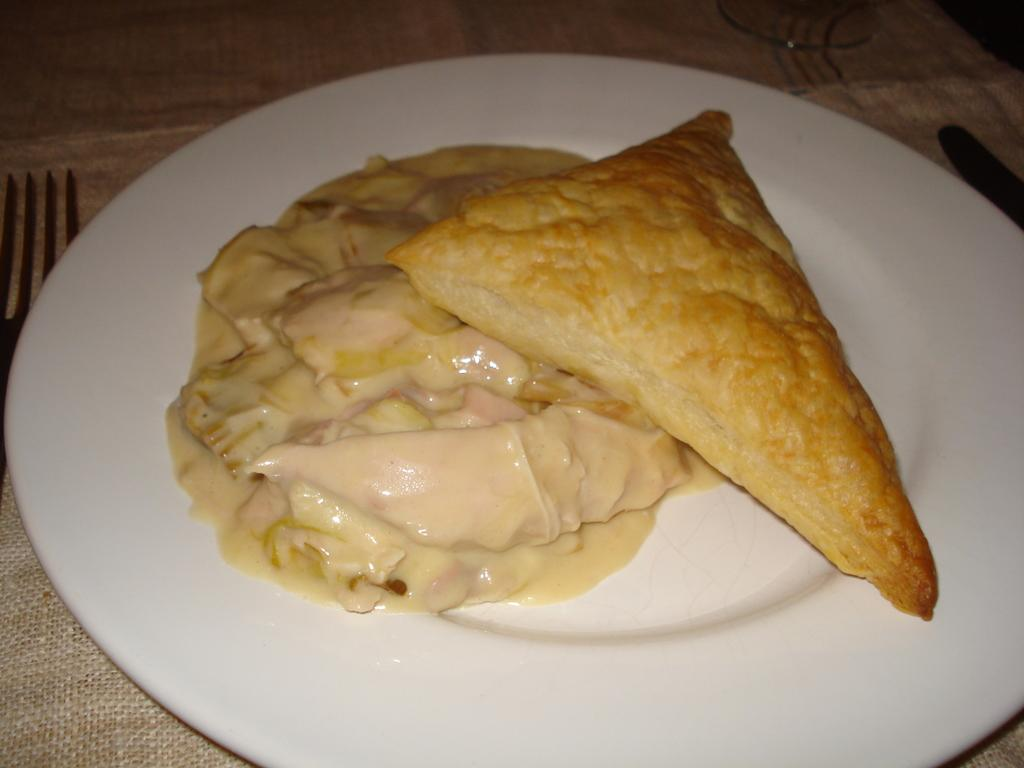What is on the table in the image? There is a plate, a fork, a cloth, and food on the table. Can you describe the utensil that is visible on the table? There is a fork on the table. What type of material is the cloth made of? The cloth on the table is made of fabric. What is the primary purpose of the items on the table? The items on the table are meant for eating food. How many snakes are slithering on the table in the image? There are no snakes present on the table in the image. What type of act is being performed on the table in the image? There is no act being performed on the table in the image. What type of tree is growing on the table in the image? There is no tree growing on the table in the image. 